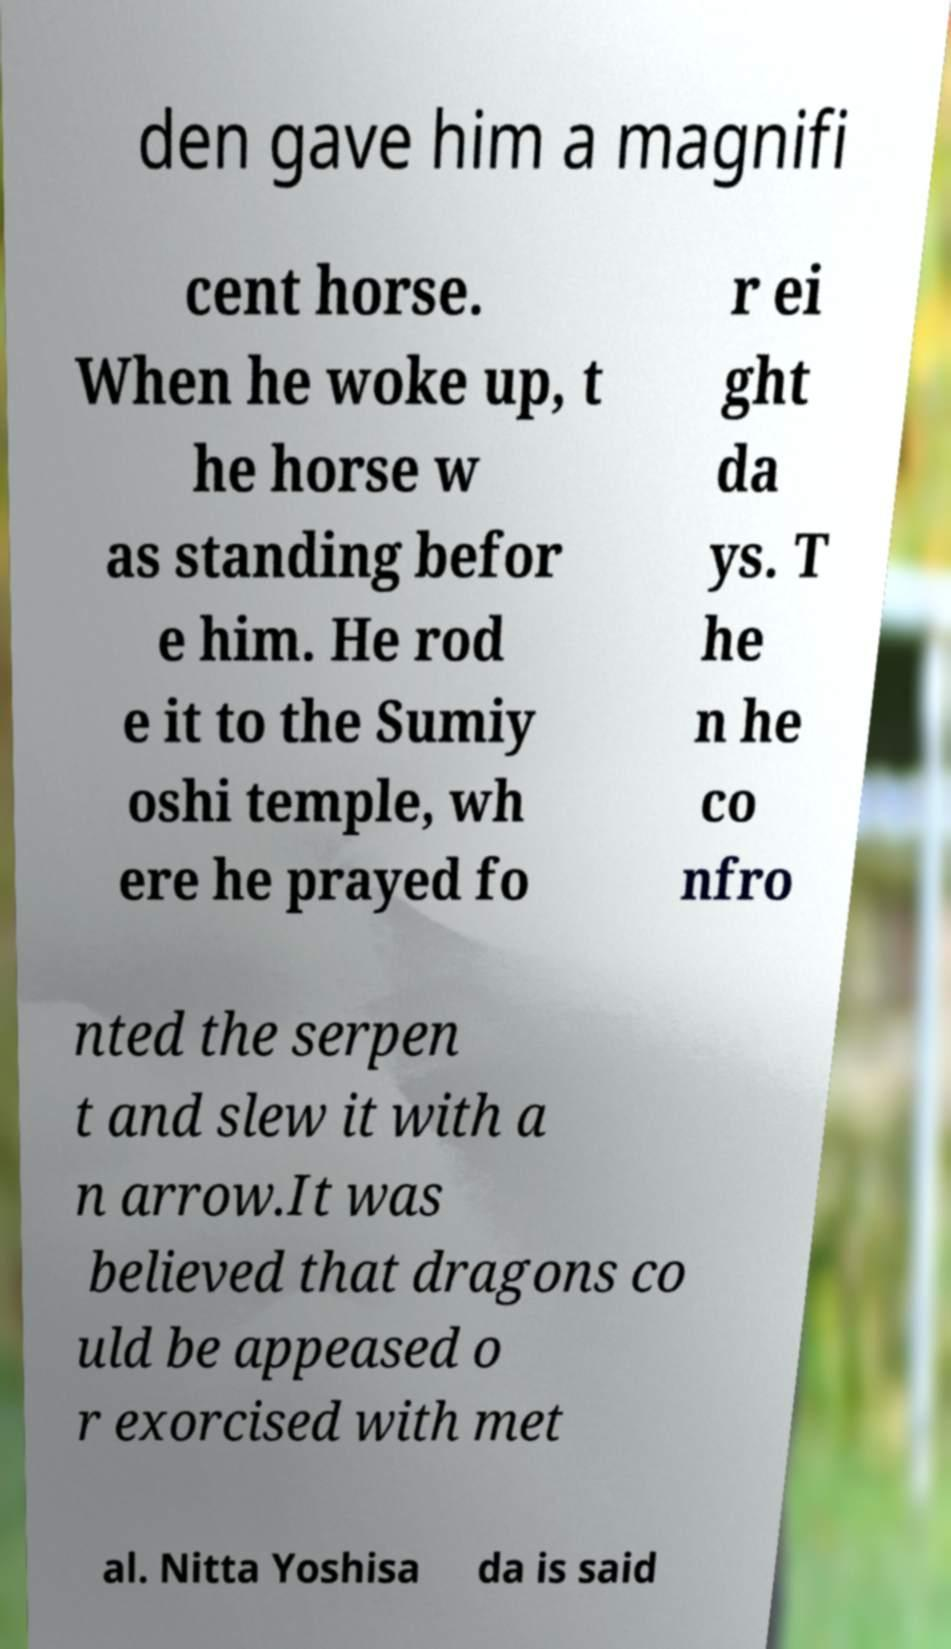There's text embedded in this image that I need extracted. Can you transcribe it verbatim? den gave him a magnifi cent horse. When he woke up, t he horse w as standing befor e him. He rod e it to the Sumiy oshi temple, wh ere he prayed fo r ei ght da ys. T he n he co nfro nted the serpen t and slew it with a n arrow.It was believed that dragons co uld be appeased o r exorcised with met al. Nitta Yoshisa da is said 